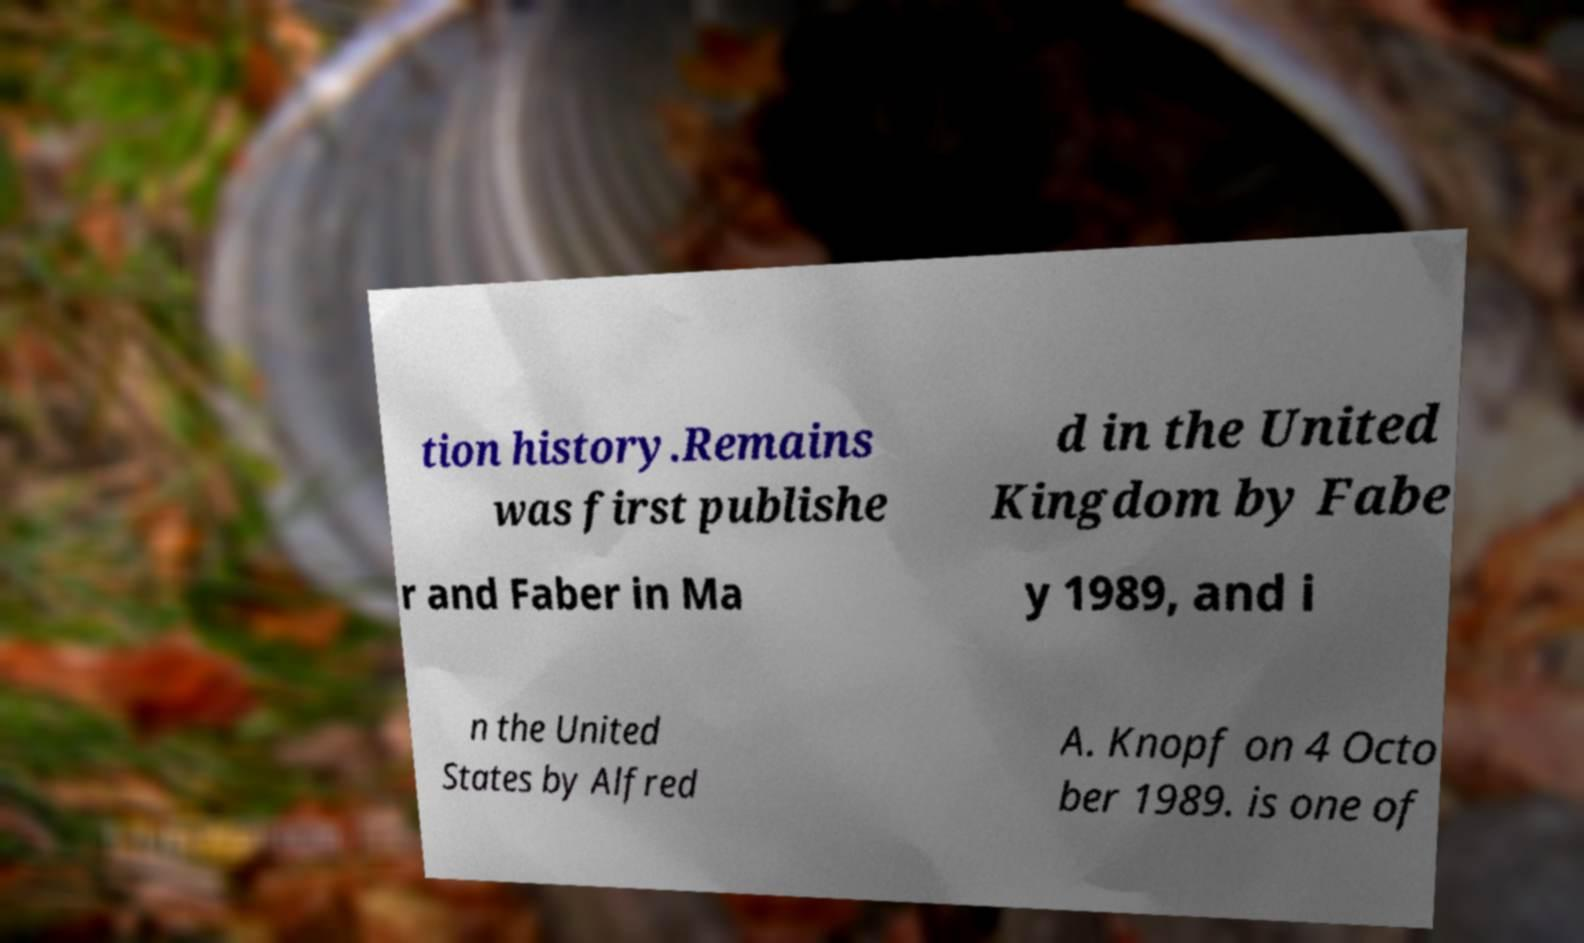For documentation purposes, I need the text within this image transcribed. Could you provide that? tion history.Remains was first publishe d in the United Kingdom by Fabe r and Faber in Ma y 1989, and i n the United States by Alfred A. Knopf on 4 Octo ber 1989. is one of 